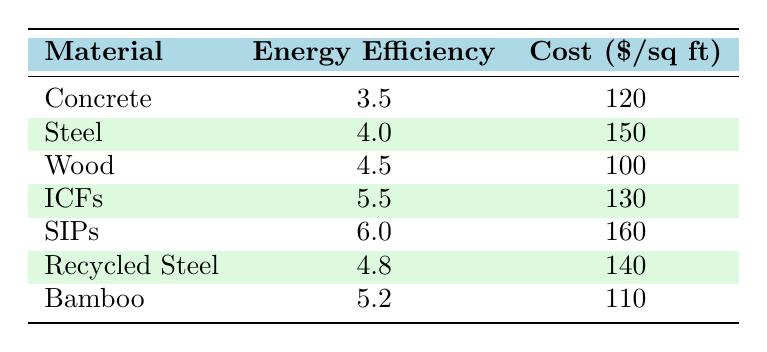What is the energy efficiency rating of Wood? The table lists the energy efficiency rating for Wood as 4.5.
Answer: 4.5 What is the construction cost per square foot for Structural Insulated Panels (SIPs)? The table indicates that the construction cost per square foot for SIPs is 160.
Answer: 160 Which material has the highest energy efficiency rating? By examining the energy efficiency ratings in the table, Structural Insulated Panels (SIPs) has the highest rating at 6.0.
Answer: Structural Insulated Panels (SIPs) What is the average construction cost per square foot of all materials listed? To find the average cost, sum the costs (120 + 150 + 100 + 130 + 160 + 140 + 110 = 1010) which totals 1010, and divide by the number of materials (7), giving an average cost of 1010/7 ≈ 144.29.
Answer: 144.29 Is the energy efficiency rating of Insulated Concrete Forms (ICFs) greater than that of Concrete? ICFs has an energy efficiency rating of 5.5, while Concrete has a rating of 3.5. Since 5.5 is greater than 3.5, the statement is true.
Answer: Yes What is the difference in energy efficiency ratings between Steel and Recycled Steel? Steel has an energy efficiency rating of 4.0, and Recycled Steel has a rating of 4.8. The difference is 4.8 - 4.0 = 0.8.
Answer: 0.8 Which two materials have energy efficiency ratings between 4.5 and 5.5? Upon reviewing the table, Wood (4.5) and Bamboo (5.2) have ratings that fall within that range.
Answer: Wood and Bamboo Is the construction cost of Bamboo lower than that of Insulated Concrete Forms (ICFs)? Bamboo's construction cost is 110, while ICFs cost 130. Since 110 is less than 130, the statement is true.
Answer: Yes 